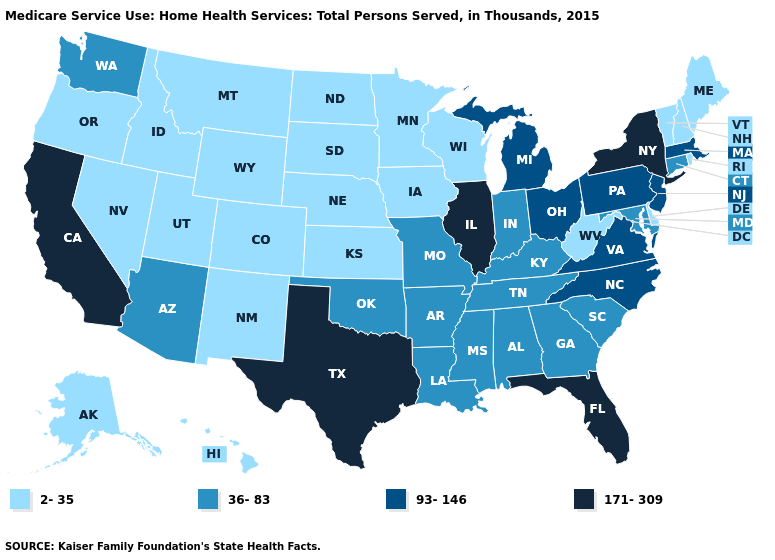What is the value of Maryland?
Answer briefly. 36-83. How many symbols are there in the legend?
Quick response, please. 4. Name the states that have a value in the range 2-35?
Give a very brief answer. Alaska, Colorado, Delaware, Hawaii, Idaho, Iowa, Kansas, Maine, Minnesota, Montana, Nebraska, Nevada, New Hampshire, New Mexico, North Dakota, Oregon, Rhode Island, South Dakota, Utah, Vermont, West Virginia, Wisconsin, Wyoming. Which states have the lowest value in the MidWest?
Be succinct. Iowa, Kansas, Minnesota, Nebraska, North Dakota, South Dakota, Wisconsin. Among the states that border Maryland , does Pennsylvania have the lowest value?
Answer briefly. No. What is the value of Mississippi?
Write a very short answer. 36-83. What is the value of Montana?
Give a very brief answer. 2-35. Name the states that have a value in the range 93-146?
Write a very short answer. Massachusetts, Michigan, New Jersey, North Carolina, Ohio, Pennsylvania, Virginia. Which states hav the highest value in the West?
Be succinct. California. Does the map have missing data?
Keep it brief. No. Among the states that border South Dakota , which have the lowest value?
Give a very brief answer. Iowa, Minnesota, Montana, Nebraska, North Dakota, Wyoming. What is the highest value in the Northeast ?
Give a very brief answer. 171-309. Does Pennsylvania have the lowest value in the Northeast?
Short answer required. No. What is the value of Oklahoma?
Write a very short answer. 36-83. Name the states that have a value in the range 93-146?
Write a very short answer. Massachusetts, Michigan, New Jersey, North Carolina, Ohio, Pennsylvania, Virginia. 